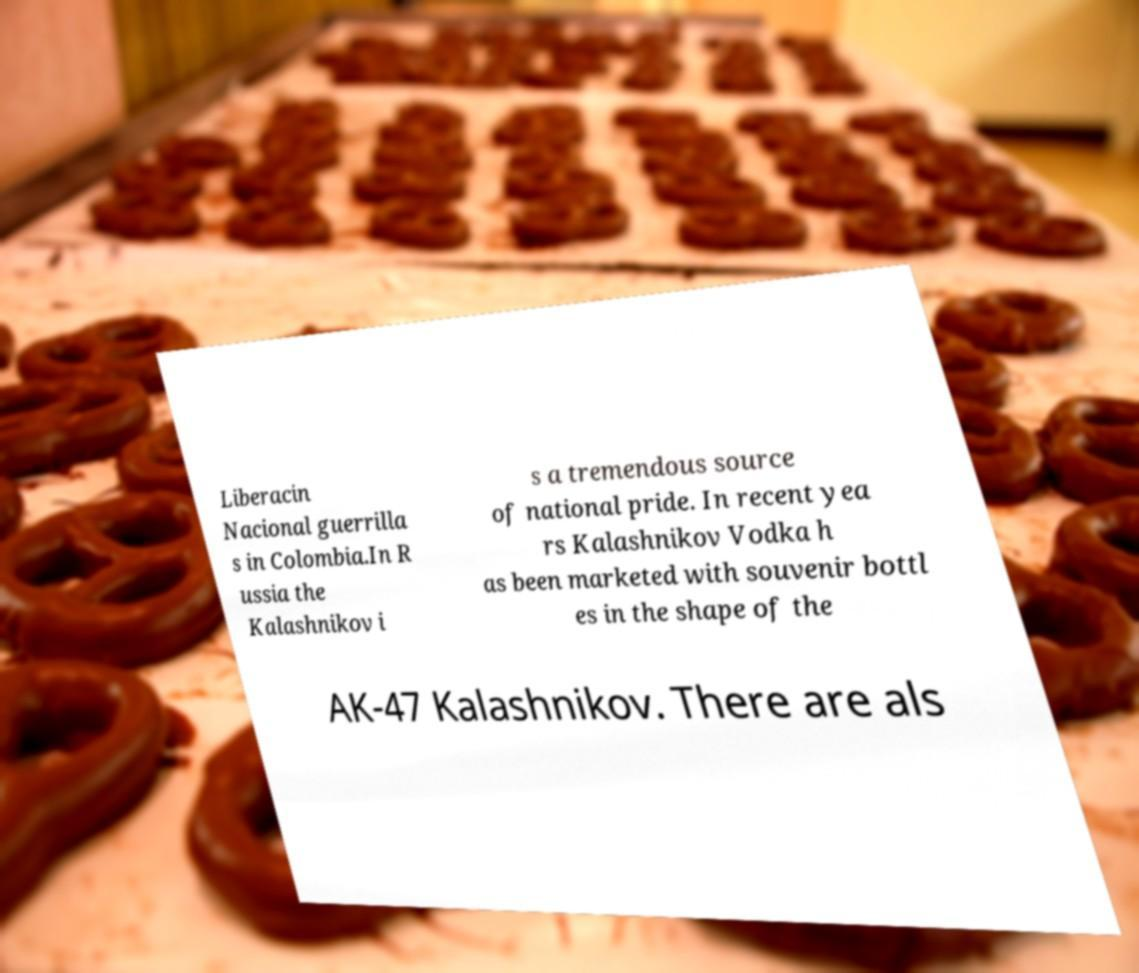There's text embedded in this image that I need extracted. Can you transcribe it verbatim? Liberacin Nacional guerrilla s in Colombia.In R ussia the Kalashnikov i s a tremendous source of national pride. In recent yea rs Kalashnikov Vodka h as been marketed with souvenir bottl es in the shape of the AK-47 Kalashnikov. There are als 